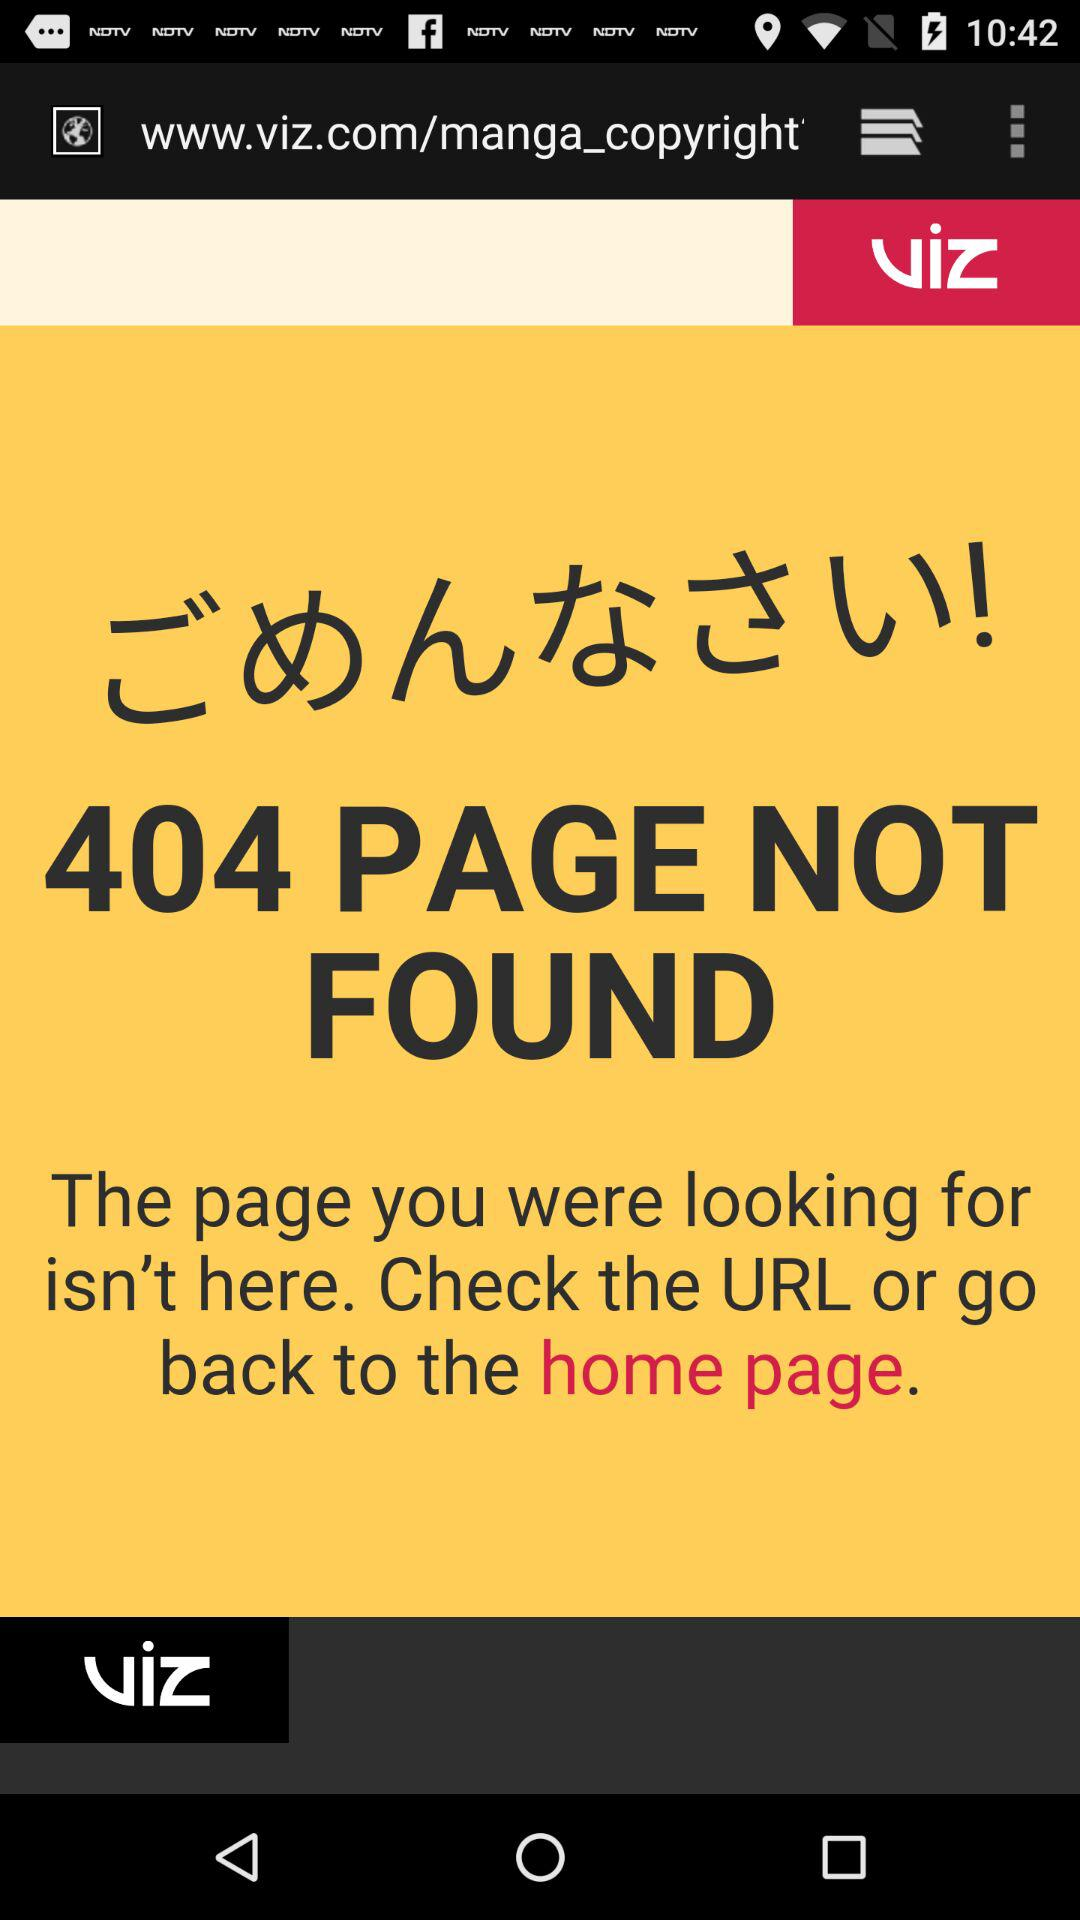How many more lines of text are there in the text 'The page you were looking for isn't here. Check the URL or go back to the home page.' than in the text '404 PAGE NOT FOUND'?
Answer the question using a single word or phrase. 1 